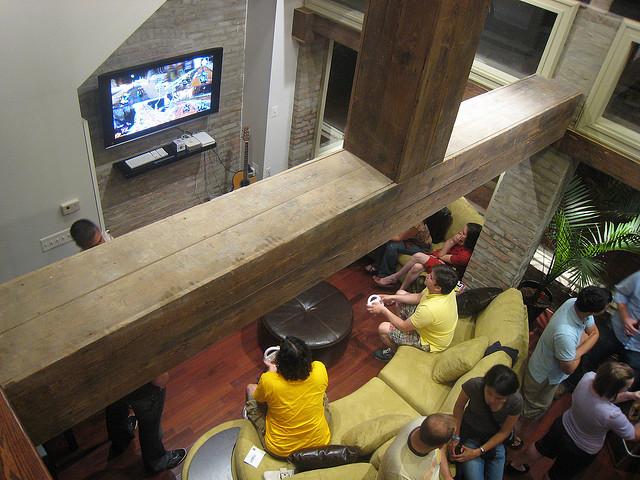What color is the couch?
Write a very short answer. Green. How many people are sitting on the back of the couch?
Be succinct. 2. Are all the people watching TV?
Be succinct. No. 